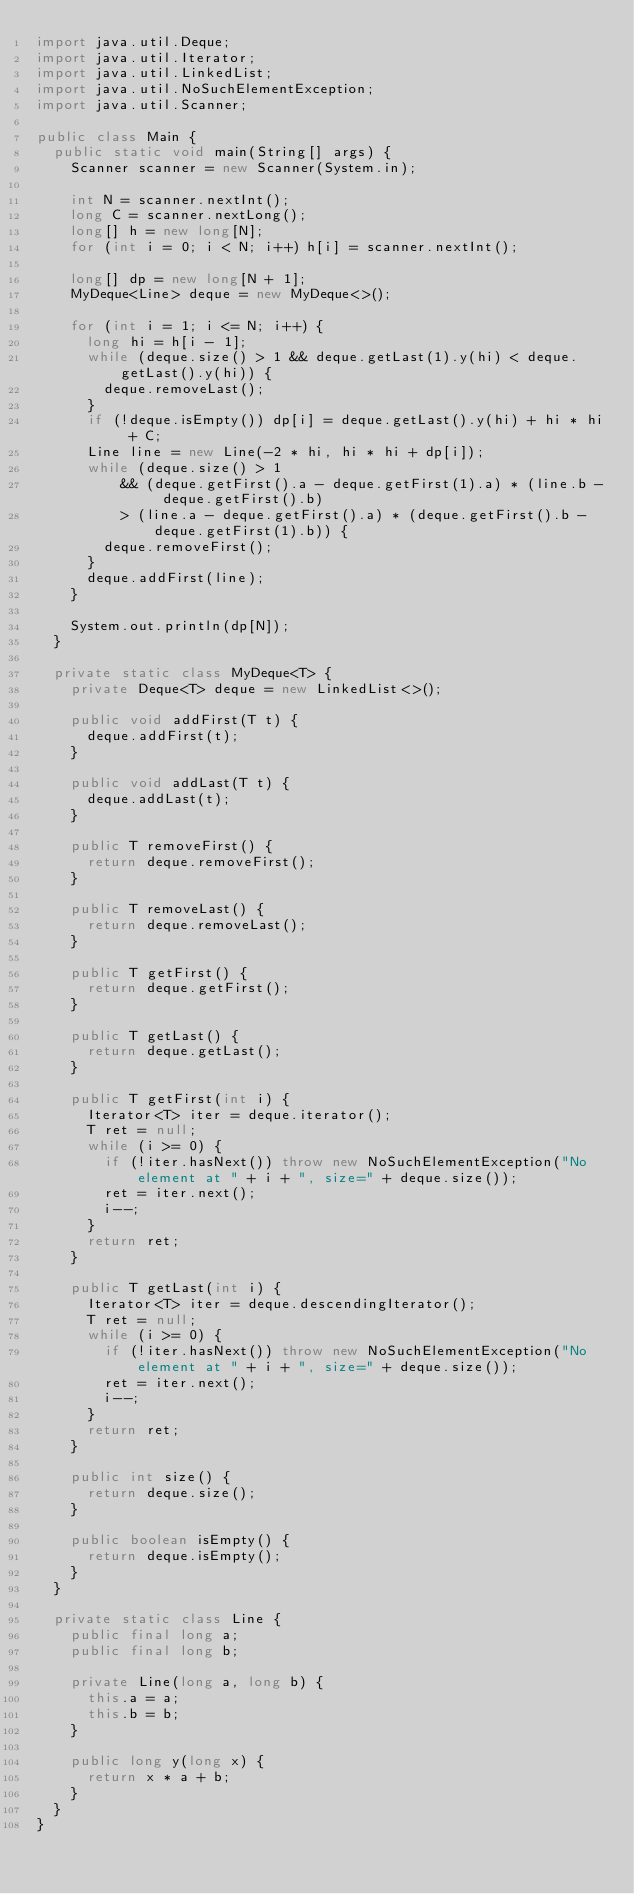<code> <loc_0><loc_0><loc_500><loc_500><_Java_>import java.util.Deque;
import java.util.Iterator;
import java.util.LinkedList;
import java.util.NoSuchElementException;
import java.util.Scanner;

public class Main {
  public static void main(String[] args) {
    Scanner scanner = new Scanner(System.in);

    int N = scanner.nextInt();
    long C = scanner.nextLong();
    long[] h = new long[N];
    for (int i = 0; i < N; i++) h[i] = scanner.nextInt();

    long[] dp = new long[N + 1];
    MyDeque<Line> deque = new MyDeque<>();

    for (int i = 1; i <= N; i++) {
      long hi = h[i - 1];
      while (deque.size() > 1 && deque.getLast(1).y(hi) < deque.getLast().y(hi)) {
        deque.removeLast();
      }
      if (!deque.isEmpty()) dp[i] = deque.getLast().y(hi) + hi * hi + C;
      Line line = new Line(-2 * hi, hi * hi + dp[i]);
      while (deque.size() > 1
          && (deque.getFirst().a - deque.getFirst(1).a) * (line.b - deque.getFirst().b)
          > (line.a - deque.getFirst().a) * (deque.getFirst().b - deque.getFirst(1).b)) {
        deque.removeFirst();
      }
      deque.addFirst(line);
    }

    System.out.println(dp[N]);
  }

  private static class MyDeque<T> {
    private Deque<T> deque = new LinkedList<>();

    public void addFirst(T t) {
      deque.addFirst(t);
    }

    public void addLast(T t) {
      deque.addLast(t);
    }

    public T removeFirst() {
      return deque.removeFirst();
    }

    public T removeLast() {
      return deque.removeLast();
    }

    public T getFirst() {
      return deque.getFirst();
    }

    public T getLast() {
      return deque.getLast();
    }

    public T getFirst(int i) {
      Iterator<T> iter = deque.iterator();
      T ret = null;
      while (i >= 0) {
        if (!iter.hasNext()) throw new NoSuchElementException("No element at " + i + ", size=" + deque.size());
        ret = iter.next();
        i--;
      }
      return ret;
    }

    public T getLast(int i) {
      Iterator<T> iter = deque.descendingIterator();
      T ret = null;
      while (i >= 0) {
        if (!iter.hasNext()) throw new NoSuchElementException("No element at " + i + ", size=" + deque.size());
        ret = iter.next();
        i--;
      }
      return ret;
    }

    public int size() {
      return deque.size();
    }

    public boolean isEmpty() {
      return deque.isEmpty();
    }
  }

  private static class Line {
    public final long a;
    public final long b;

    private Line(long a, long b) {
      this.a = a;
      this.b = b;
    }

    public long y(long x) {
      return x * a + b;
    }
  }
}
</code> 